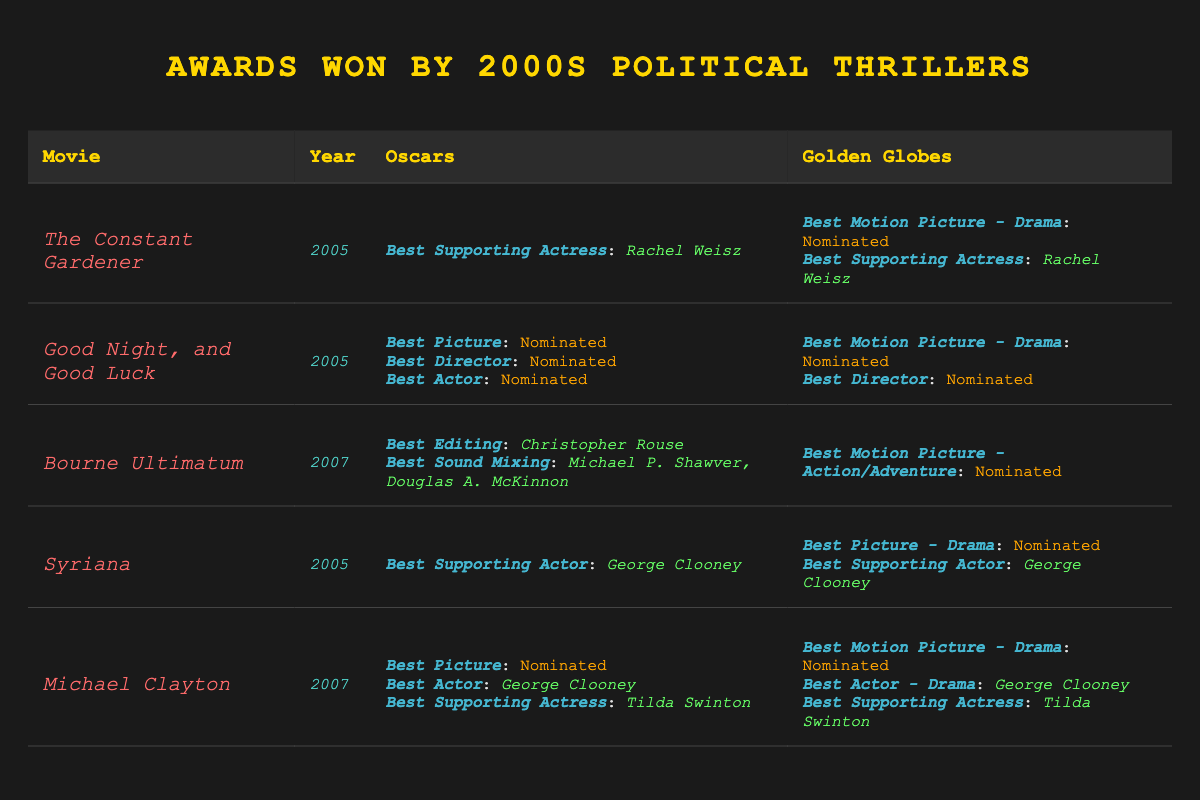What award did Rachel Weisz win for *The Constant Gardener*? According to the table, Rachel Weisz won the *Best Supporting Actress* Oscar for *The Constant Gardener*.
Answer: *Best Supporting Actress* Oscar How many Oscars did *Good Night, and Good Luck* receive nominations for? The table indicates that *Good Night, and Good Luck* received nominations in three categories: *Best Picture*, *Best Director*, and *Best Actor*.
Answer: 3 nominations Did *Syriana* win any Golden Globes? The table shows that while *Syriana* received nominations for two categories, it did not win any Golden Globes.
Answer: No Which movie won an Oscar for *Best Editing*? The data indicates that *Bourne Ultimatum* won the Oscar for *Best Editing*, awarded to Christopher Rouse.
Answer: *Bourne Ultimatum* What is the total number of awards won by *Michael Clayton* across both the Oscars and the Golden Globes? *Michael Clayton* won two Oscars (for *Best Actor* and *Best Supporting Actress*) and two Golden Globes (also for *Best Actor - Drama* and *Best Supporting Actress*), totaling four awards.
Answer: 4 awards Which actor won the *Best Actor* Oscar for a political thriller in the 2000s? The table reveals that George Clooney won the *Best Actor* Oscar for *Michael Clayton*.
Answer: George Clooney How many movies in the table were nominated for *Best Motion Picture - Drama* at the Golden Globes? Both *The Constant Gardener* and *Good Night, and Good Luck* were nominated for this category, leading to a total of two movies.
Answer: 2 movies What year did *Bourne Ultimatum* win its Oscars? Referring to the table, *Bourne Ultimatum* won its Oscars in 2007.
Answer: 2007 Which movie received the most nominations across both awards? *Good Night, and Good Luck* received three Oscar nominations and two Golden Globe nominations, totaling five nominations, making it the movie with the most nominations.
Answer: *Good Night, and Good Luck* Was any movie nominated for *Best Picture* at the Oscars while also being nominated for *Best Motion Picture - Drama* at the Golden Globes? Yes, both *Good Night, and Good Luck* and *Michael Clayton* were nominated for *Best Picture* at the Oscars and also for *Best Motion Picture - Drama* at the Golden Globes.
Answer: Yes 